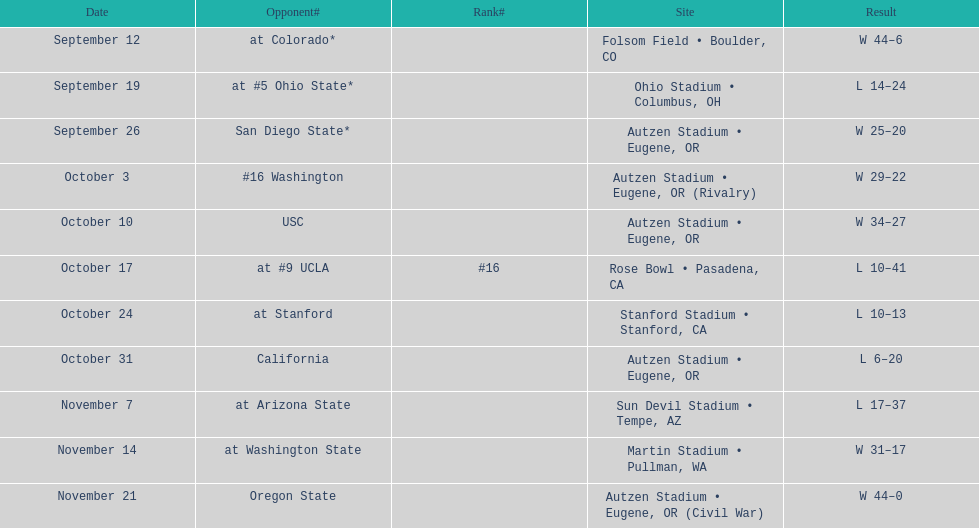What is the quantity of away games? 6. 